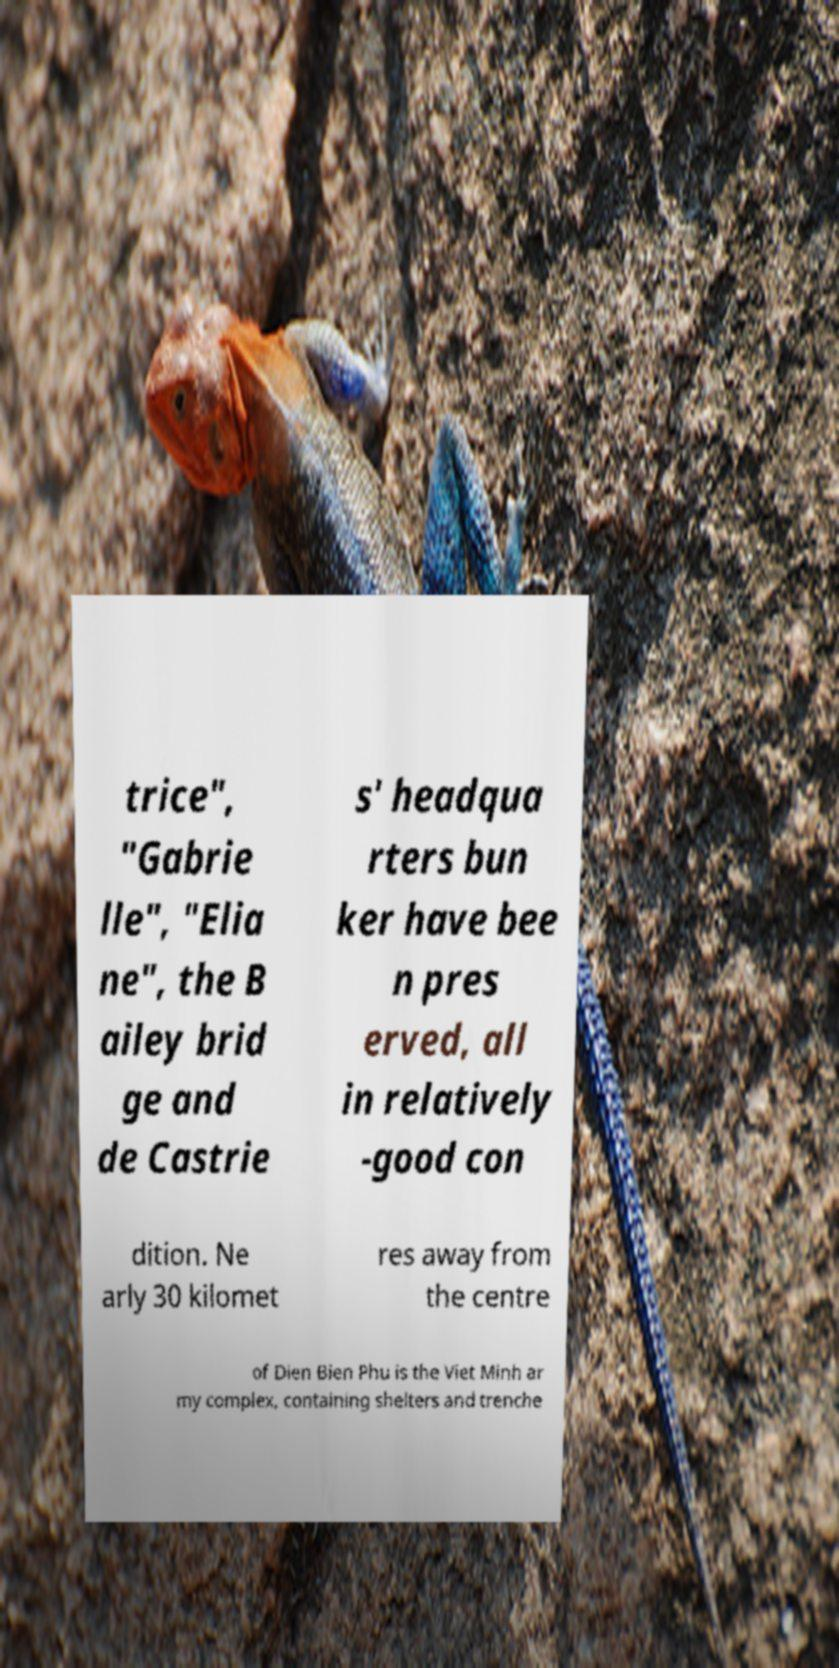Please identify and transcribe the text found in this image. trice", "Gabrie lle", "Elia ne", the B ailey brid ge and de Castrie s' headqua rters bun ker have bee n pres erved, all in relatively -good con dition. Ne arly 30 kilomet res away from the centre of Dien Bien Phu is the Viet Minh ar my complex, containing shelters and trenche 